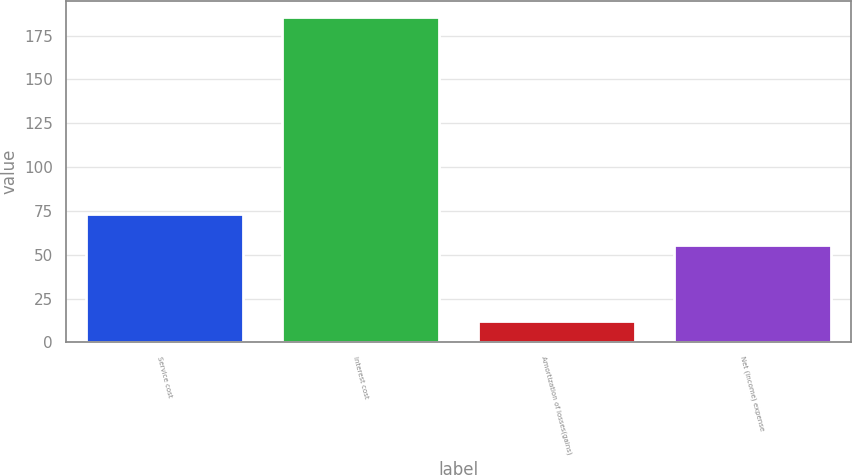<chart> <loc_0><loc_0><loc_500><loc_500><bar_chart><fcel>Service cost<fcel>Interest cost<fcel>Amortization of losses(gains)<fcel>Net (income) expense<nl><fcel>73.11<fcel>185.6<fcel>12.5<fcel>55.8<nl></chart> 